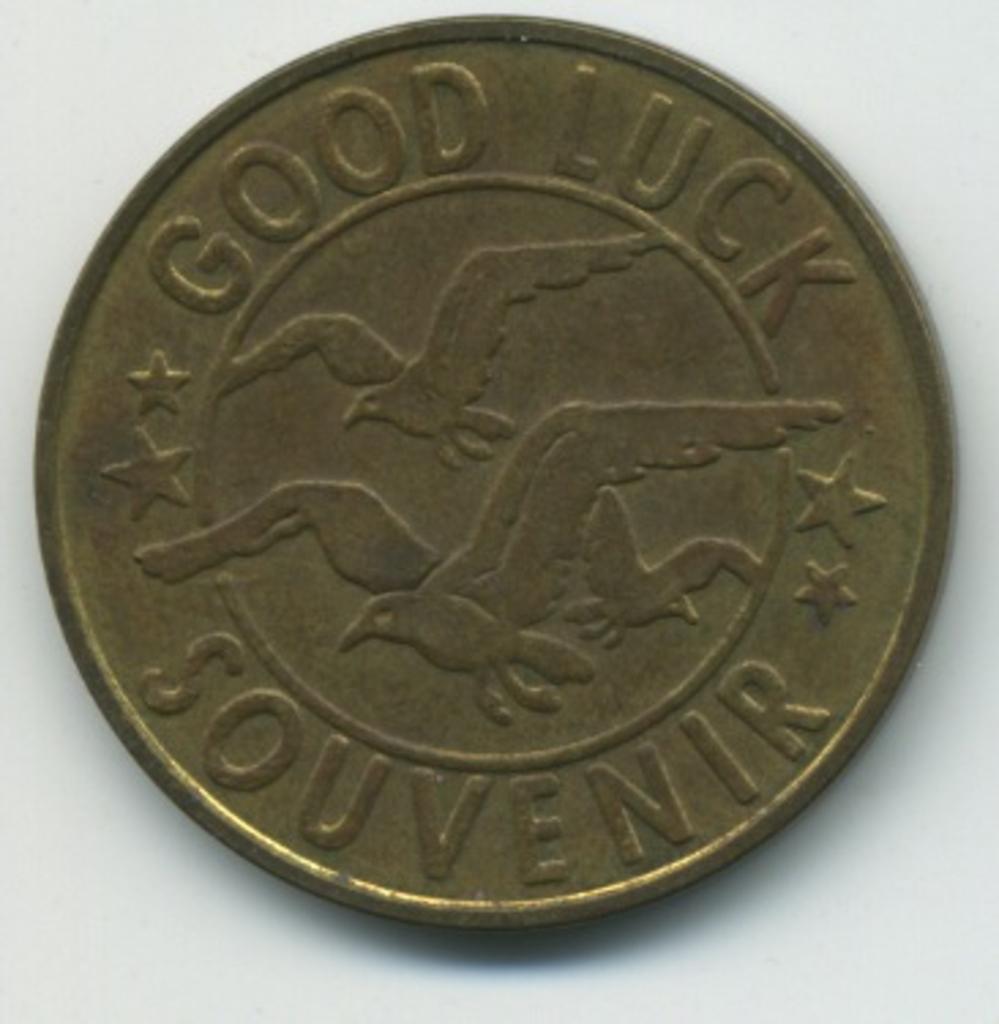What kind of coin is this?
Provide a short and direct response. Good luck souvenir. What is written on the coin?
Provide a succinct answer. Good luck souvenir. 